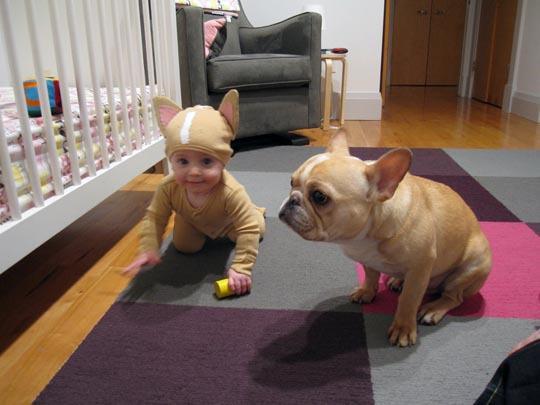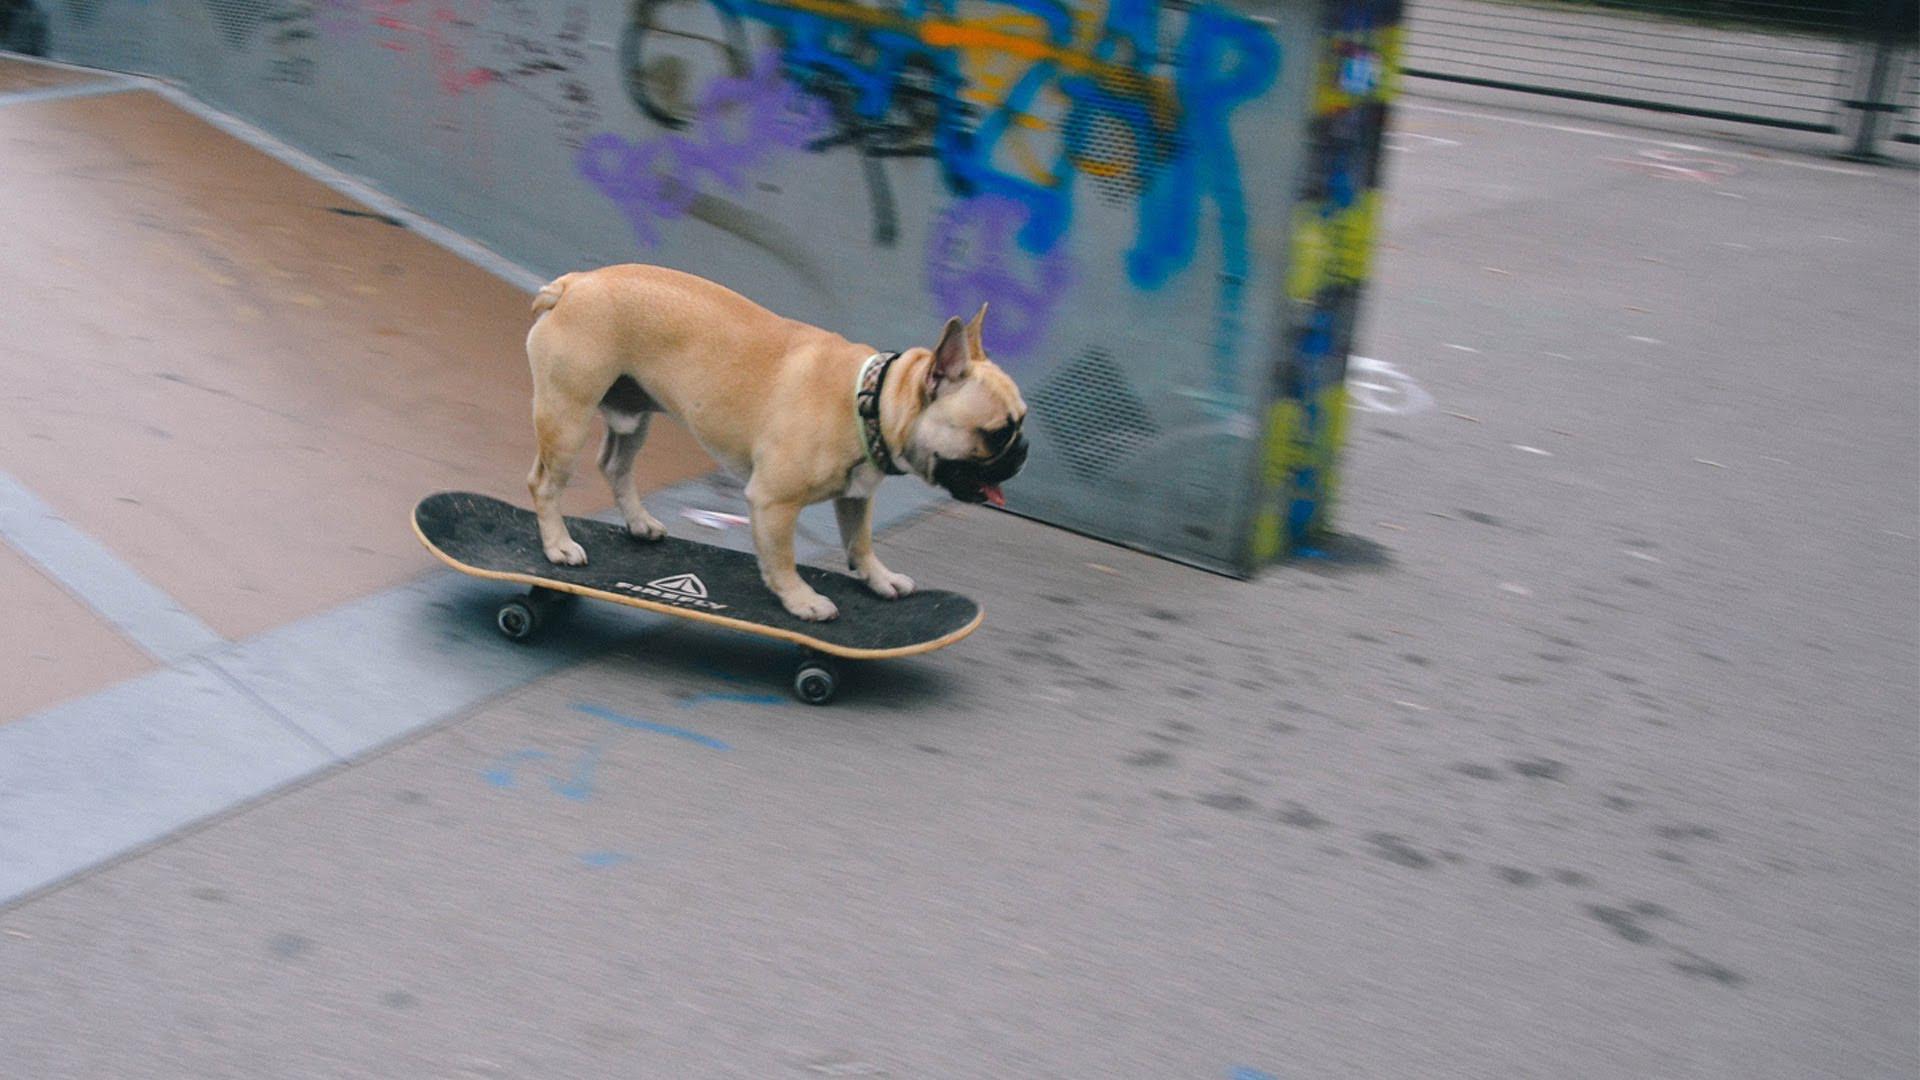The first image is the image on the left, the second image is the image on the right. Evaluate the accuracy of this statement regarding the images: "A small dog is perched on a black skateboard with black wheels.". Is it true? Answer yes or no. Yes. The first image is the image on the left, the second image is the image on the right. Given the left and right images, does the statement "At least one image features more than one dog on a skateboard." hold true? Answer yes or no. No. 